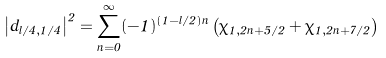<formula> <loc_0><loc_0><loc_500><loc_500>\left | d _ { l / 4 , 1 / 4 } \right | ^ { 2 } = \sum _ { n = 0 } ^ { \infty } ( - 1 ) ^ { ( 1 - l / 2 ) n } \left ( \chi _ { 1 , 2 n + 5 / 2 } + \chi _ { 1 , 2 n + 7 / 2 } \right )</formula> 